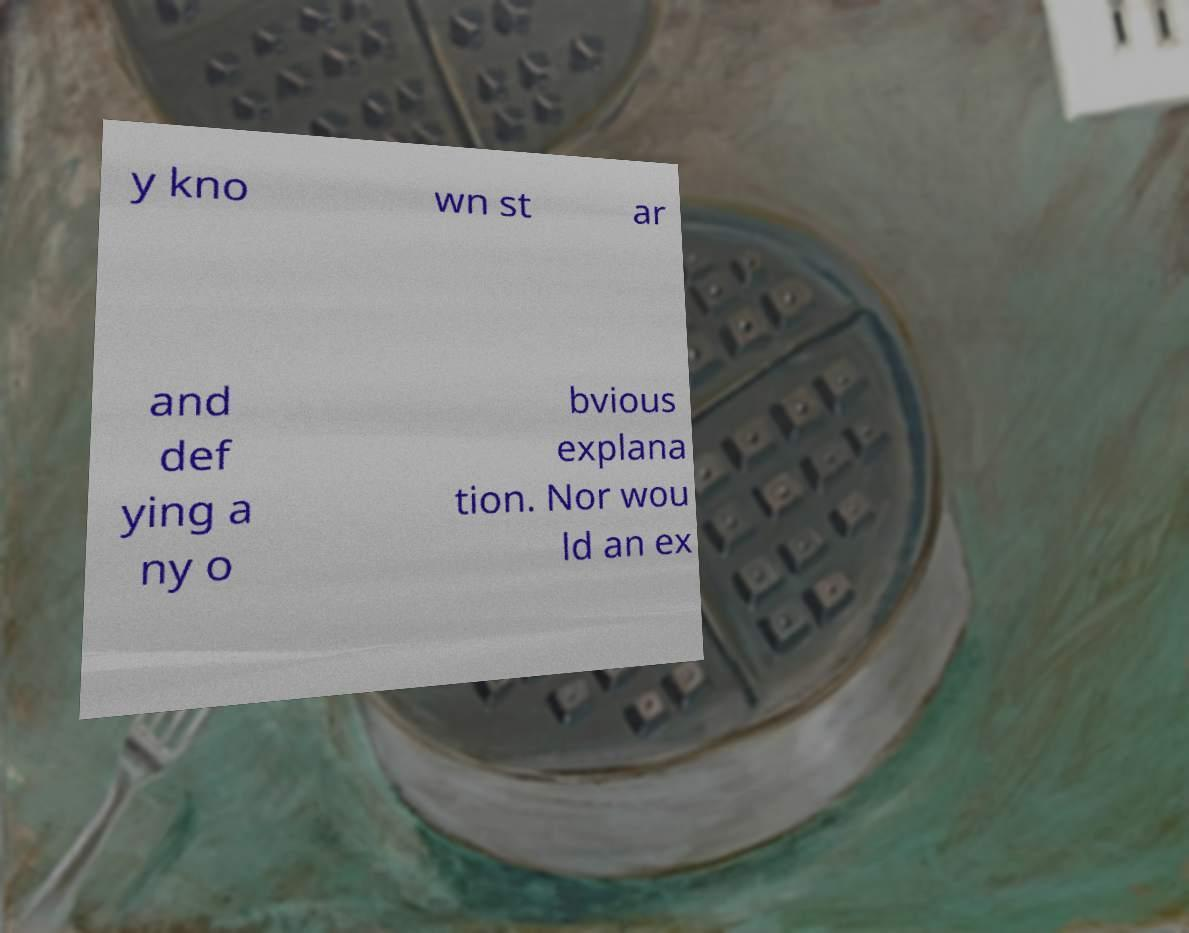Can you accurately transcribe the text from the provided image for me? y kno wn st ar and def ying a ny o bvious explana tion. Nor wou ld an ex 